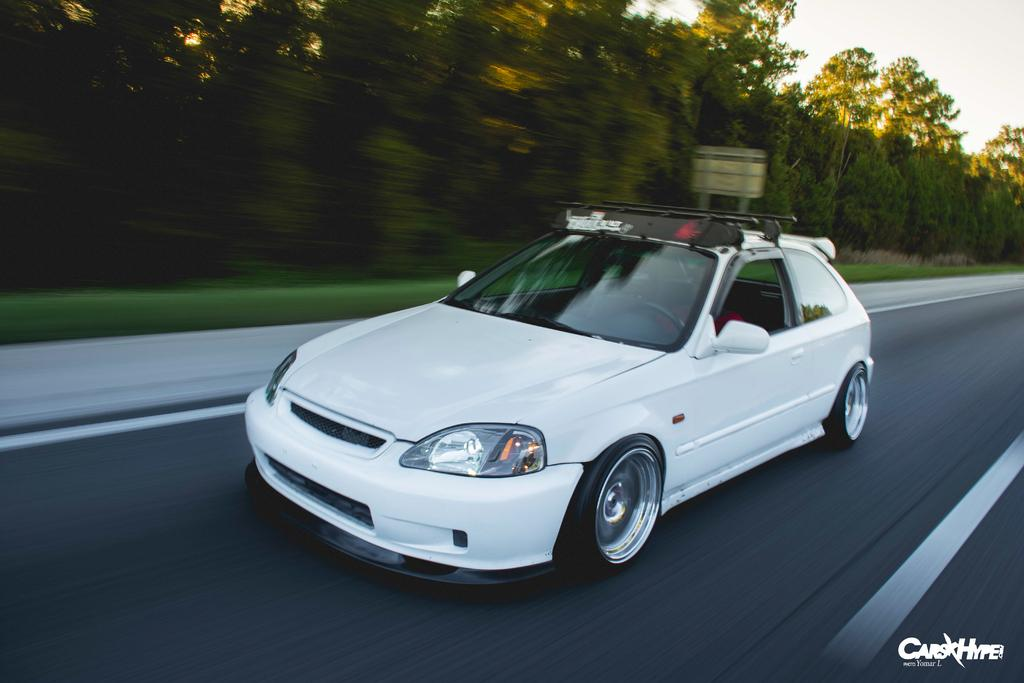What is the man doing in the image? The man is riding a car in the image. Where is the car located? The car is on the road in the image. What can be seen in the background of the image? There are trees, grass, a board, and the sky visible in the background of the image. What type of science experiment is being conducted on the wall in the image? There is no wall or science experiment present in the image. 